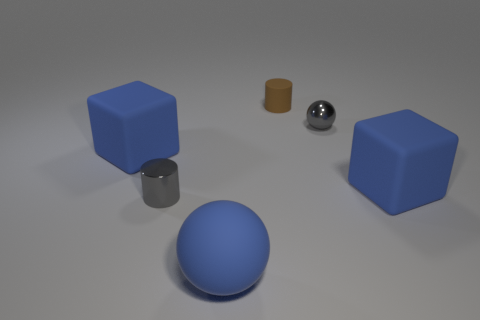Add 1 brown matte cylinders. How many objects exist? 7 Subtract all cylinders. How many objects are left? 4 Subtract all gray cylinders. How many cylinders are left? 1 Add 5 big blue things. How many big blue things are left? 8 Add 4 brown matte things. How many brown matte things exist? 5 Subtract 0 red cylinders. How many objects are left? 6 Subtract 1 blocks. How many blocks are left? 1 Subtract all cyan blocks. Subtract all brown cylinders. How many blocks are left? 2 Subtract all small cyan cubes. Subtract all large blue things. How many objects are left? 3 